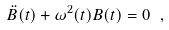<formula> <loc_0><loc_0><loc_500><loc_500>\ddot { B } ( t ) + \omega ^ { 2 } ( t ) B ( t ) = 0 \ ,</formula> 